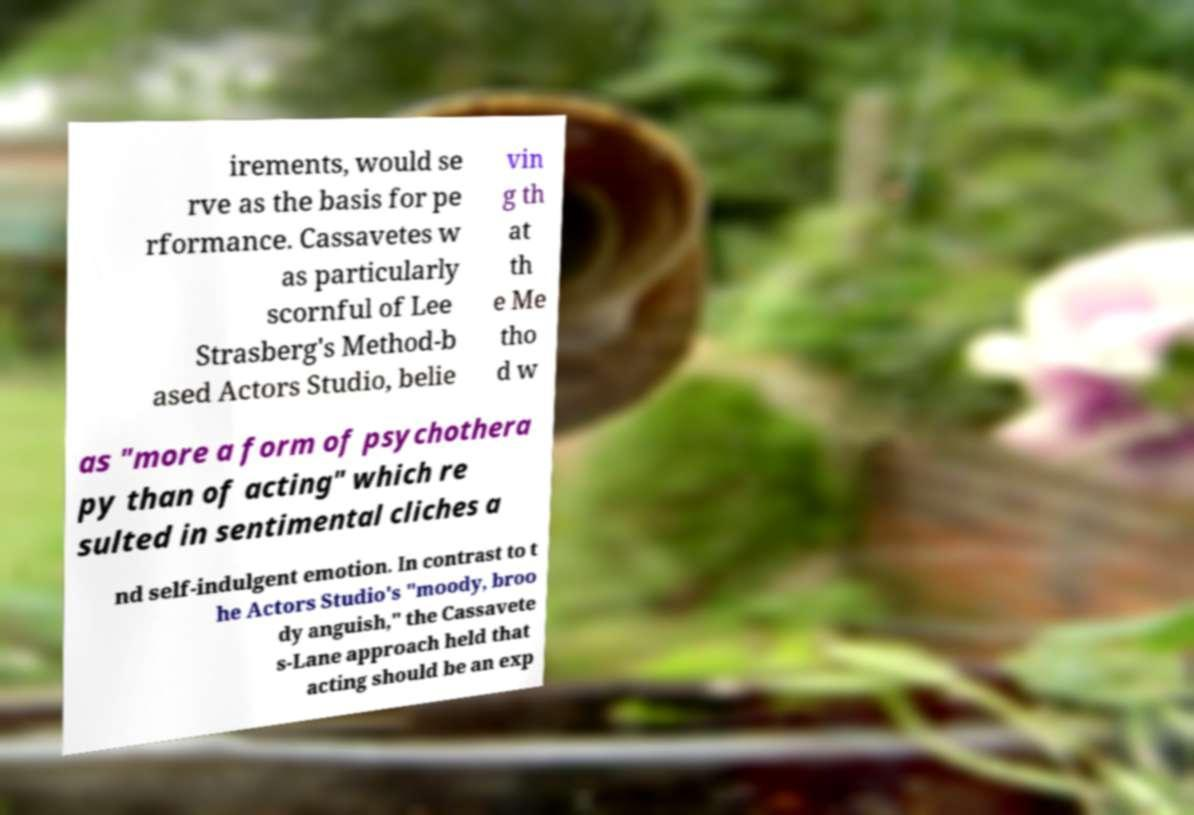Could you assist in decoding the text presented in this image and type it out clearly? irements, would se rve as the basis for pe rformance. Cassavetes w as particularly scornful of Lee Strasberg's Method-b ased Actors Studio, belie vin g th at th e Me tho d w as "more a form of psychothera py than of acting" which re sulted in sentimental cliches a nd self-indulgent emotion. In contrast to t he Actors Studio's "moody, broo dy anguish," the Cassavete s-Lane approach held that acting should be an exp 